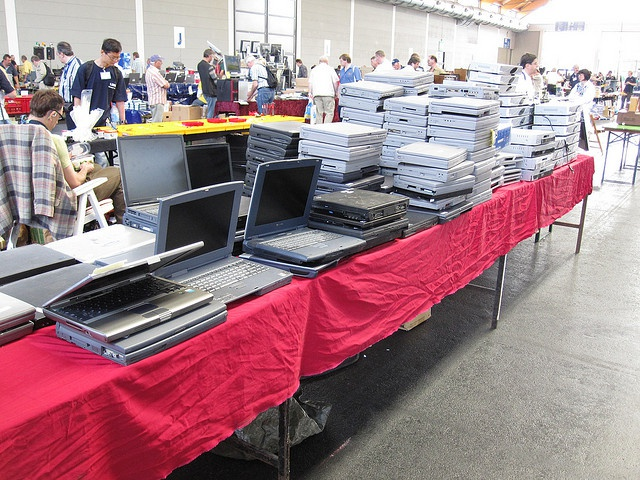Describe the objects in this image and their specific colors. I can see laptop in lightgray, black, gray, and darkgray tones, laptop in lightgray, black, gray, and darkgray tones, people in lightgray, white, gray, darkgray, and pink tones, laptop in lightgray, black, navy, and darkgray tones, and laptop in lightgray, gray, darkgray, and black tones in this image. 